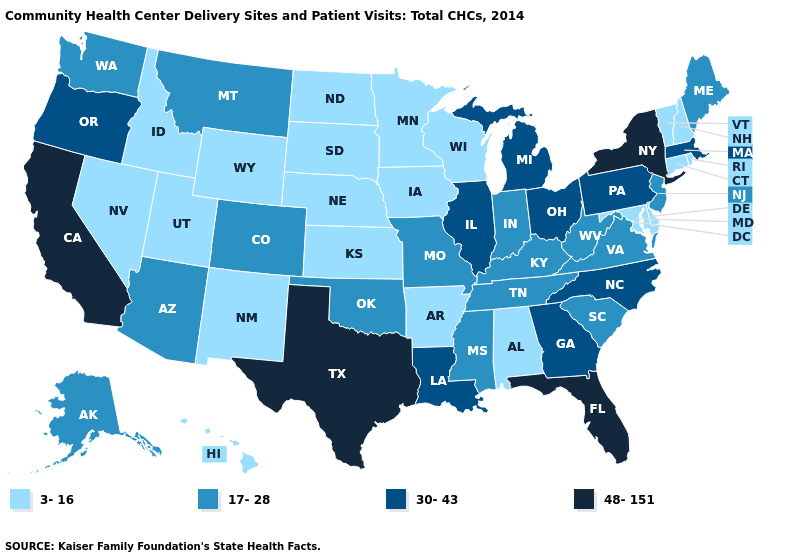Does the first symbol in the legend represent the smallest category?
Write a very short answer. Yes. Which states hav the highest value in the Northeast?
Quick response, please. New York. Among the states that border Maryland , which have the highest value?
Give a very brief answer. Pennsylvania. What is the value of Louisiana?
Give a very brief answer. 30-43. Which states have the lowest value in the USA?
Give a very brief answer. Alabama, Arkansas, Connecticut, Delaware, Hawaii, Idaho, Iowa, Kansas, Maryland, Minnesota, Nebraska, Nevada, New Hampshire, New Mexico, North Dakota, Rhode Island, South Dakota, Utah, Vermont, Wisconsin, Wyoming. Which states hav the highest value in the West?
Write a very short answer. California. Name the states that have a value in the range 48-151?
Quick response, please. California, Florida, New York, Texas. Name the states that have a value in the range 30-43?
Answer briefly. Georgia, Illinois, Louisiana, Massachusetts, Michigan, North Carolina, Ohio, Oregon, Pennsylvania. Does California have the lowest value in the West?
Concise answer only. No. Among the states that border North Dakota , does Montana have the lowest value?
Write a very short answer. No. What is the value of Wyoming?
Short answer required. 3-16. Is the legend a continuous bar?
Write a very short answer. No. Which states hav the highest value in the MidWest?
Write a very short answer. Illinois, Michigan, Ohio. Which states have the lowest value in the West?
Write a very short answer. Hawaii, Idaho, Nevada, New Mexico, Utah, Wyoming. 